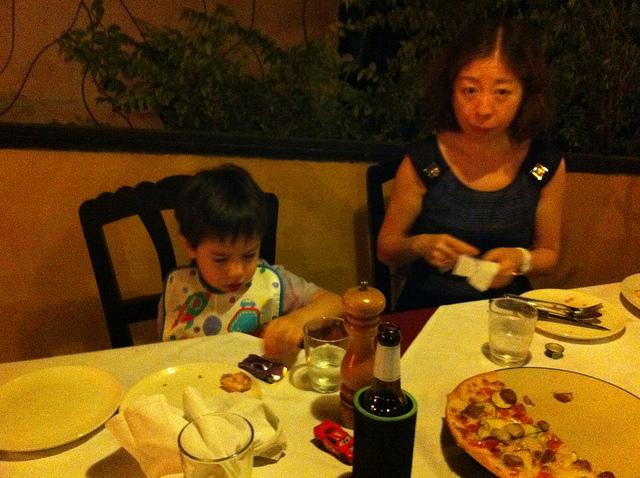What will the woman ask for to take the leftover pizza home in?
Be succinct. Box. Are they eating?
Give a very brief answer. Yes. What is the little boy wearing around his neck?
Short answer required. Bib. What is on the painting behind the table?
Concise answer only. Plants. 